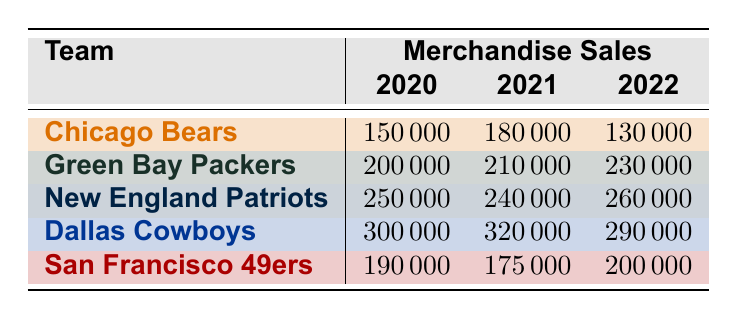What was the merchandise sales amount for the Chicago Bears in 2021? In the 2021 row for the Chicago Bears, the sales amount listed is 180000. Thus, this value represents the merchandise sales for that team in that year.
Answer: 180000 Which team had the highest merchandise sales in 2020? By comparing the sales values in the 2020 column, the Dallas Cowboys have the highest sales at 300000, followed by the New England Patriots with 250000.
Answer: Dallas Cowboys What is the total merchandise sales for the Green Bay Packers over the three years? The total can be calculated by summing the sales amounts for the Green Bay Packers across years: 200000 + 210000 + 230000 = 640000.
Answer: 640000 Did the San Francisco 49ers have higher merchandise sales in 2022 than in 2021? The merchandise sales for the San Francisco 49ers in 2022 is 200000, which is higher than the 2021 sales of 175000, confirming that their sales increased.
Answer: Yes What is the difference in merchandise sales between the New England Patriots in 2020 and 2022? The sales for the New England Patriots are 250000 in 2020 and 260000 in 2022. The difference is computed as 260000 - 250000 = 10000.
Answer: 10000 Which team had the least merchandise sales in 2022? The merchandise sales for each team in 2022 must be compared, where the Chicago Bears had the least with 130000 compared to others: Green Bay Packers (230000), New England Patriots (260000), Dallas Cowboys (290000), and San Francisco 49ers (200000).
Answer: Chicago Bears What was the average merchandise sales for the Dallas Cowboys from 2020 to 2022? To find the average, add the sales amounts (300000 + 320000 + 290000 = 910000) and then divide by the number of years (3), resulting in 910000 / 3 = 303333.33.
Answer: 303333.33 Was the merchandise sale for the Chicago Bears consistent over the years? Looking at the sales amounts for the Chicago Bears across the years: 150000 in 2020, 180000 in 2021, and 130000 in 2022, we see fluctuations which indicates inconsistency in their sales.
Answer: No 